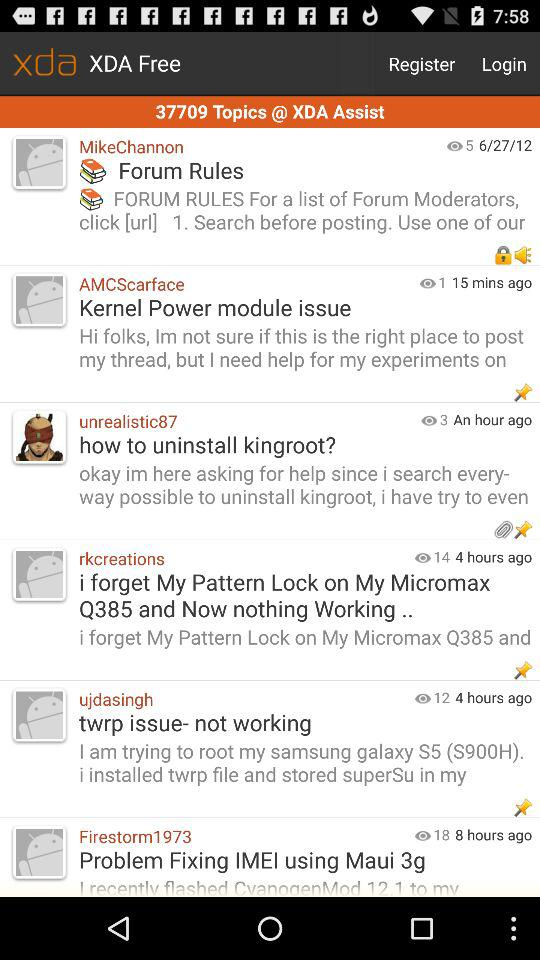How many views of AMCScarface's post are there? There is 1 view of AMCScarface's post. 